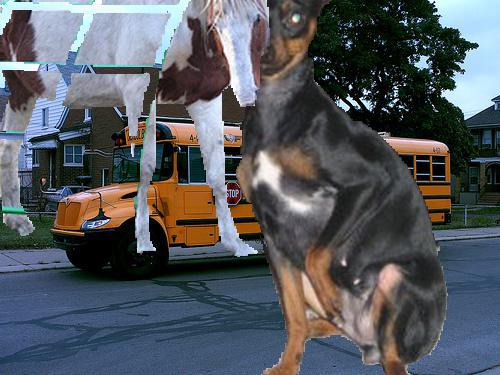Can you describe the setting behind the dog? Behind the outsized dog, there's a suburban street with houses that have front yards and a sidewalk. There is a yellow school bus parked by the curb, which is common in residential areas during school days. Do the houses suggest a particular style or time period? The architectural style of the houses, with their pitched roofs and front porches, is characteristic of mid-20th century suburban development in many regions of North America. 